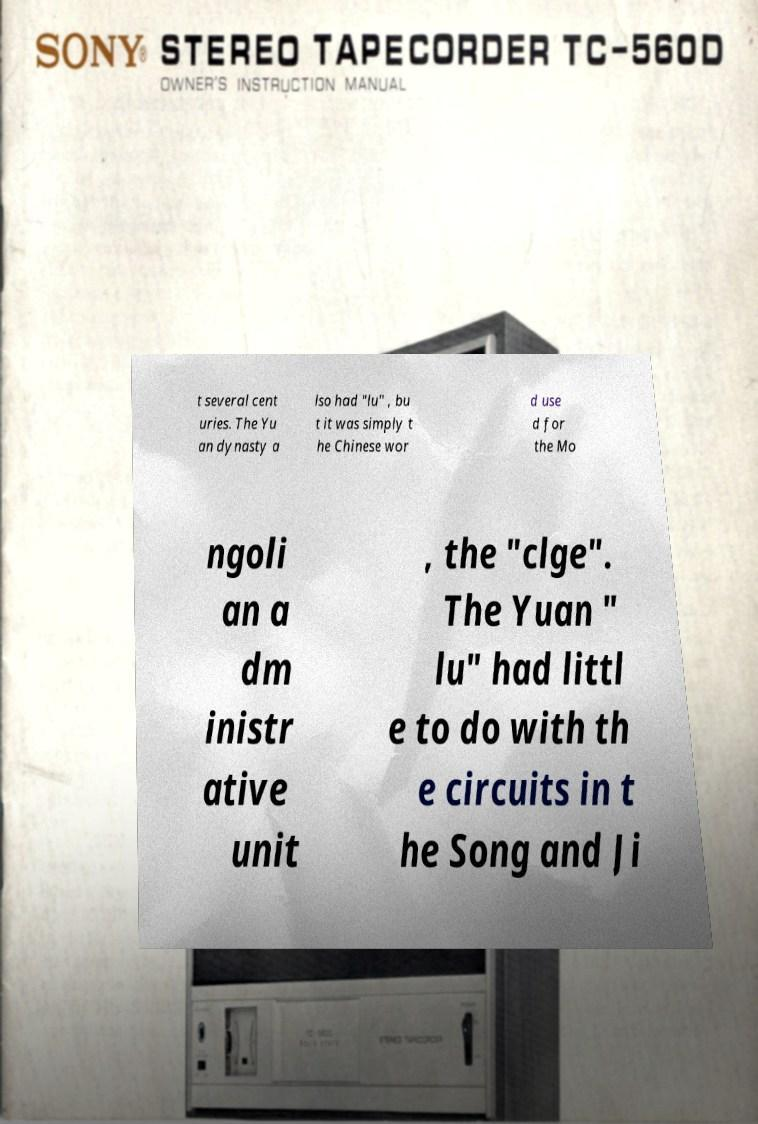For documentation purposes, I need the text within this image transcribed. Could you provide that? t several cent uries. The Yu an dynasty a lso had "lu" , bu t it was simply t he Chinese wor d use d for the Mo ngoli an a dm inistr ative unit , the "clge". The Yuan " lu" had littl e to do with th e circuits in t he Song and Ji 